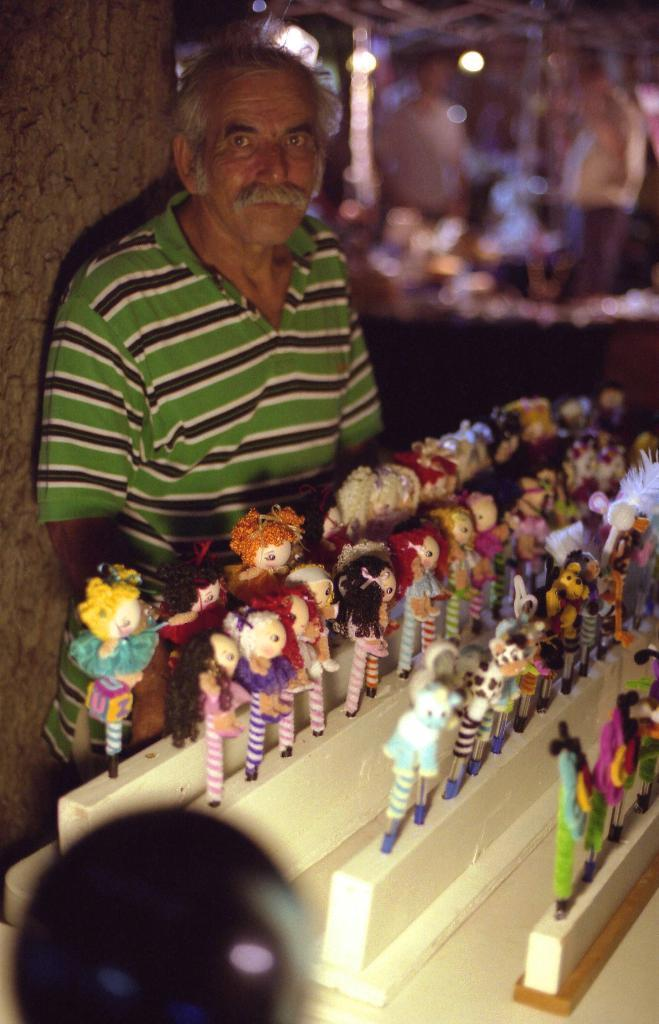Who is present in the image? There is a man in the image. Where is the man located in the image? The man is on the left side of the image. What is the man doing in the image? The man is standing. What is the man wearing in the image? The man is wearing clothes. What else can be seen in the image besides the man? There are many toys of different colors in the image. How would you describe the background of the image? The background of the image is blurred. What time is displayed on the clock in the image? There is no clock present in the image. What is the size of the rail in the image? There is no rail present in the image. 